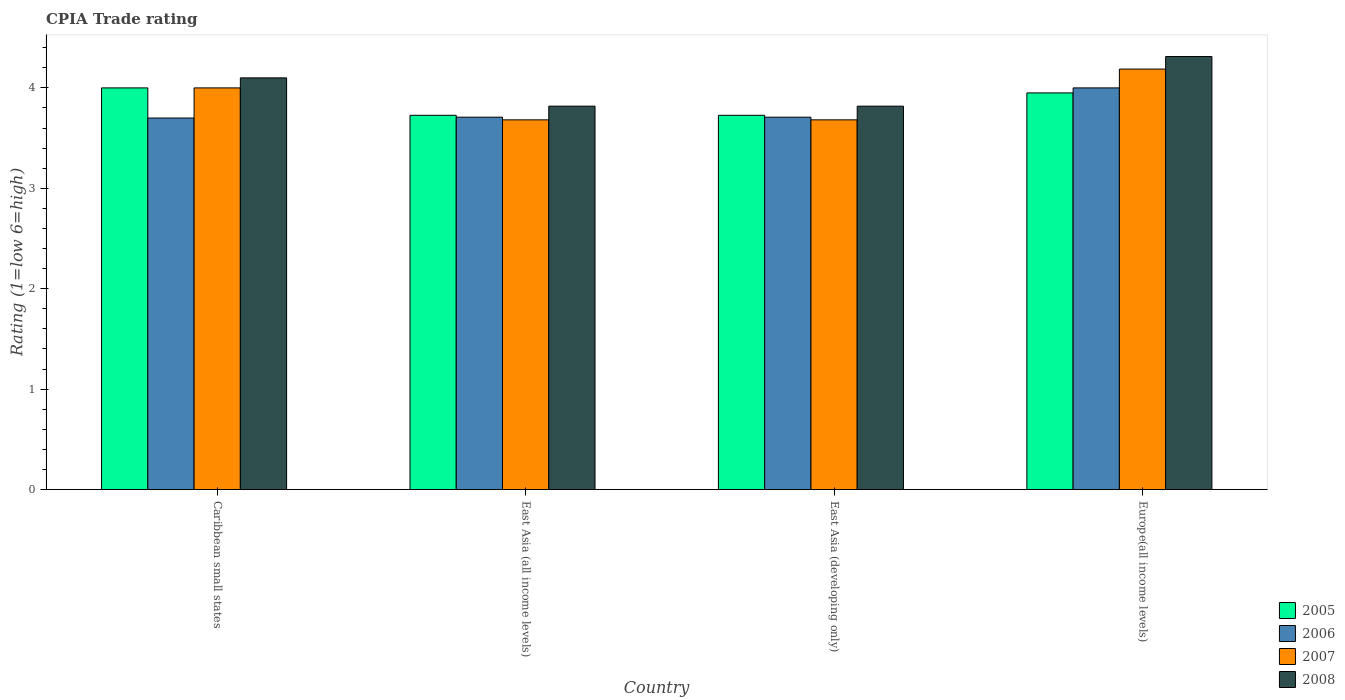Are the number of bars per tick equal to the number of legend labels?
Ensure brevity in your answer.  Yes. Are the number of bars on each tick of the X-axis equal?
Ensure brevity in your answer.  Yes. How many bars are there on the 3rd tick from the right?
Keep it short and to the point. 4. What is the label of the 3rd group of bars from the left?
Keep it short and to the point. East Asia (developing only). What is the CPIA rating in 2007 in East Asia (developing only)?
Offer a very short reply. 3.68. Across all countries, what is the minimum CPIA rating in 2008?
Make the answer very short. 3.82. In which country was the CPIA rating in 2005 maximum?
Your answer should be compact. Caribbean small states. In which country was the CPIA rating in 2008 minimum?
Offer a very short reply. East Asia (all income levels). What is the total CPIA rating in 2006 in the graph?
Offer a very short reply. 15.12. What is the difference between the CPIA rating in 2008 in East Asia (all income levels) and that in Europe(all income levels)?
Provide a succinct answer. -0.49. What is the average CPIA rating in 2005 per country?
Offer a very short reply. 3.85. What is the difference between the CPIA rating of/in 2006 and CPIA rating of/in 2005 in Caribbean small states?
Give a very brief answer. -0.3. What is the ratio of the CPIA rating in 2007 in Caribbean small states to that in East Asia (developing only)?
Keep it short and to the point. 1.09. Is the CPIA rating in 2005 in Caribbean small states less than that in East Asia (all income levels)?
Provide a short and direct response. No. What is the difference between the highest and the second highest CPIA rating in 2006?
Make the answer very short. -0.29. What is the difference between the highest and the lowest CPIA rating in 2007?
Provide a succinct answer. 0.51. Is the sum of the CPIA rating in 2007 in Caribbean small states and East Asia (all income levels) greater than the maximum CPIA rating in 2008 across all countries?
Your answer should be very brief. Yes. Is it the case that in every country, the sum of the CPIA rating in 2007 and CPIA rating in 2008 is greater than the sum of CPIA rating in 2005 and CPIA rating in 2006?
Your response must be concise. Yes. What does the 1st bar from the right in East Asia (developing only) represents?
Ensure brevity in your answer.  2008. Is it the case that in every country, the sum of the CPIA rating in 2006 and CPIA rating in 2007 is greater than the CPIA rating in 2008?
Provide a short and direct response. Yes. How many bars are there?
Make the answer very short. 16. How many countries are there in the graph?
Provide a succinct answer. 4. Are the values on the major ticks of Y-axis written in scientific E-notation?
Keep it short and to the point. No. Does the graph contain any zero values?
Your answer should be very brief. No. Does the graph contain grids?
Keep it short and to the point. No. How many legend labels are there?
Make the answer very short. 4. How are the legend labels stacked?
Ensure brevity in your answer.  Vertical. What is the title of the graph?
Your answer should be compact. CPIA Trade rating. Does "1965" appear as one of the legend labels in the graph?
Keep it short and to the point. No. What is the Rating (1=low 6=high) in 2005 in Caribbean small states?
Your answer should be compact. 4. What is the Rating (1=low 6=high) of 2006 in Caribbean small states?
Provide a short and direct response. 3.7. What is the Rating (1=low 6=high) of 2005 in East Asia (all income levels)?
Your response must be concise. 3.73. What is the Rating (1=low 6=high) of 2006 in East Asia (all income levels)?
Make the answer very short. 3.71. What is the Rating (1=low 6=high) of 2007 in East Asia (all income levels)?
Your response must be concise. 3.68. What is the Rating (1=low 6=high) in 2008 in East Asia (all income levels)?
Give a very brief answer. 3.82. What is the Rating (1=low 6=high) in 2005 in East Asia (developing only)?
Ensure brevity in your answer.  3.73. What is the Rating (1=low 6=high) in 2006 in East Asia (developing only)?
Your response must be concise. 3.71. What is the Rating (1=low 6=high) of 2007 in East Asia (developing only)?
Your response must be concise. 3.68. What is the Rating (1=low 6=high) in 2008 in East Asia (developing only)?
Keep it short and to the point. 3.82. What is the Rating (1=low 6=high) in 2005 in Europe(all income levels)?
Offer a terse response. 3.95. What is the Rating (1=low 6=high) in 2007 in Europe(all income levels)?
Your response must be concise. 4.19. What is the Rating (1=low 6=high) in 2008 in Europe(all income levels)?
Give a very brief answer. 4.31. Across all countries, what is the maximum Rating (1=low 6=high) in 2006?
Give a very brief answer. 4. Across all countries, what is the maximum Rating (1=low 6=high) of 2007?
Keep it short and to the point. 4.19. Across all countries, what is the maximum Rating (1=low 6=high) of 2008?
Offer a very short reply. 4.31. Across all countries, what is the minimum Rating (1=low 6=high) of 2005?
Your answer should be compact. 3.73. Across all countries, what is the minimum Rating (1=low 6=high) of 2006?
Offer a very short reply. 3.7. Across all countries, what is the minimum Rating (1=low 6=high) of 2007?
Keep it short and to the point. 3.68. Across all countries, what is the minimum Rating (1=low 6=high) in 2008?
Your answer should be very brief. 3.82. What is the total Rating (1=low 6=high) of 2005 in the graph?
Ensure brevity in your answer.  15.4. What is the total Rating (1=low 6=high) in 2006 in the graph?
Keep it short and to the point. 15.12. What is the total Rating (1=low 6=high) in 2007 in the graph?
Provide a short and direct response. 15.55. What is the total Rating (1=low 6=high) in 2008 in the graph?
Your answer should be very brief. 16.05. What is the difference between the Rating (1=low 6=high) of 2005 in Caribbean small states and that in East Asia (all income levels)?
Your answer should be compact. 0.27. What is the difference between the Rating (1=low 6=high) of 2006 in Caribbean small states and that in East Asia (all income levels)?
Your response must be concise. -0.01. What is the difference between the Rating (1=low 6=high) in 2007 in Caribbean small states and that in East Asia (all income levels)?
Your answer should be compact. 0.32. What is the difference between the Rating (1=low 6=high) of 2008 in Caribbean small states and that in East Asia (all income levels)?
Provide a short and direct response. 0.28. What is the difference between the Rating (1=low 6=high) of 2005 in Caribbean small states and that in East Asia (developing only)?
Keep it short and to the point. 0.27. What is the difference between the Rating (1=low 6=high) in 2006 in Caribbean small states and that in East Asia (developing only)?
Your answer should be compact. -0.01. What is the difference between the Rating (1=low 6=high) of 2007 in Caribbean small states and that in East Asia (developing only)?
Offer a terse response. 0.32. What is the difference between the Rating (1=low 6=high) in 2008 in Caribbean small states and that in East Asia (developing only)?
Your answer should be compact. 0.28. What is the difference between the Rating (1=low 6=high) in 2005 in Caribbean small states and that in Europe(all income levels)?
Your response must be concise. 0.05. What is the difference between the Rating (1=low 6=high) in 2006 in Caribbean small states and that in Europe(all income levels)?
Provide a succinct answer. -0.3. What is the difference between the Rating (1=low 6=high) of 2007 in Caribbean small states and that in Europe(all income levels)?
Keep it short and to the point. -0.19. What is the difference between the Rating (1=low 6=high) of 2008 in Caribbean small states and that in Europe(all income levels)?
Make the answer very short. -0.21. What is the difference between the Rating (1=low 6=high) in 2005 in East Asia (all income levels) and that in East Asia (developing only)?
Keep it short and to the point. 0. What is the difference between the Rating (1=low 6=high) in 2008 in East Asia (all income levels) and that in East Asia (developing only)?
Provide a succinct answer. 0. What is the difference between the Rating (1=low 6=high) of 2005 in East Asia (all income levels) and that in Europe(all income levels)?
Make the answer very short. -0.22. What is the difference between the Rating (1=low 6=high) in 2006 in East Asia (all income levels) and that in Europe(all income levels)?
Make the answer very short. -0.29. What is the difference between the Rating (1=low 6=high) of 2007 in East Asia (all income levels) and that in Europe(all income levels)?
Keep it short and to the point. -0.51. What is the difference between the Rating (1=low 6=high) of 2008 in East Asia (all income levels) and that in Europe(all income levels)?
Your response must be concise. -0.49. What is the difference between the Rating (1=low 6=high) of 2005 in East Asia (developing only) and that in Europe(all income levels)?
Make the answer very short. -0.22. What is the difference between the Rating (1=low 6=high) in 2006 in East Asia (developing only) and that in Europe(all income levels)?
Your answer should be compact. -0.29. What is the difference between the Rating (1=low 6=high) of 2007 in East Asia (developing only) and that in Europe(all income levels)?
Your response must be concise. -0.51. What is the difference between the Rating (1=low 6=high) in 2008 in East Asia (developing only) and that in Europe(all income levels)?
Your answer should be very brief. -0.49. What is the difference between the Rating (1=low 6=high) in 2005 in Caribbean small states and the Rating (1=low 6=high) in 2006 in East Asia (all income levels)?
Offer a very short reply. 0.29. What is the difference between the Rating (1=low 6=high) of 2005 in Caribbean small states and the Rating (1=low 6=high) of 2007 in East Asia (all income levels)?
Provide a short and direct response. 0.32. What is the difference between the Rating (1=low 6=high) in 2005 in Caribbean small states and the Rating (1=low 6=high) in 2008 in East Asia (all income levels)?
Offer a very short reply. 0.18. What is the difference between the Rating (1=low 6=high) in 2006 in Caribbean small states and the Rating (1=low 6=high) in 2007 in East Asia (all income levels)?
Make the answer very short. 0.02. What is the difference between the Rating (1=low 6=high) of 2006 in Caribbean small states and the Rating (1=low 6=high) of 2008 in East Asia (all income levels)?
Offer a terse response. -0.12. What is the difference between the Rating (1=low 6=high) of 2007 in Caribbean small states and the Rating (1=low 6=high) of 2008 in East Asia (all income levels)?
Your answer should be compact. 0.18. What is the difference between the Rating (1=low 6=high) in 2005 in Caribbean small states and the Rating (1=low 6=high) in 2006 in East Asia (developing only)?
Provide a short and direct response. 0.29. What is the difference between the Rating (1=low 6=high) of 2005 in Caribbean small states and the Rating (1=low 6=high) of 2007 in East Asia (developing only)?
Provide a succinct answer. 0.32. What is the difference between the Rating (1=low 6=high) of 2005 in Caribbean small states and the Rating (1=low 6=high) of 2008 in East Asia (developing only)?
Make the answer very short. 0.18. What is the difference between the Rating (1=low 6=high) of 2006 in Caribbean small states and the Rating (1=low 6=high) of 2007 in East Asia (developing only)?
Offer a very short reply. 0.02. What is the difference between the Rating (1=low 6=high) in 2006 in Caribbean small states and the Rating (1=low 6=high) in 2008 in East Asia (developing only)?
Keep it short and to the point. -0.12. What is the difference between the Rating (1=low 6=high) in 2007 in Caribbean small states and the Rating (1=low 6=high) in 2008 in East Asia (developing only)?
Your answer should be very brief. 0.18. What is the difference between the Rating (1=low 6=high) of 2005 in Caribbean small states and the Rating (1=low 6=high) of 2007 in Europe(all income levels)?
Your answer should be very brief. -0.19. What is the difference between the Rating (1=low 6=high) in 2005 in Caribbean small states and the Rating (1=low 6=high) in 2008 in Europe(all income levels)?
Your answer should be compact. -0.31. What is the difference between the Rating (1=low 6=high) of 2006 in Caribbean small states and the Rating (1=low 6=high) of 2007 in Europe(all income levels)?
Give a very brief answer. -0.49. What is the difference between the Rating (1=low 6=high) in 2006 in Caribbean small states and the Rating (1=low 6=high) in 2008 in Europe(all income levels)?
Offer a very short reply. -0.61. What is the difference between the Rating (1=low 6=high) of 2007 in Caribbean small states and the Rating (1=low 6=high) of 2008 in Europe(all income levels)?
Keep it short and to the point. -0.31. What is the difference between the Rating (1=low 6=high) of 2005 in East Asia (all income levels) and the Rating (1=low 6=high) of 2006 in East Asia (developing only)?
Provide a short and direct response. 0.02. What is the difference between the Rating (1=low 6=high) of 2005 in East Asia (all income levels) and the Rating (1=low 6=high) of 2007 in East Asia (developing only)?
Offer a terse response. 0.05. What is the difference between the Rating (1=low 6=high) of 2005 in East Asia (all income levels) and the Rating (1=low 6=high) of 2008 in East Asia (developing only)?
Provide a short and direct response. -0.09. What is the difference between the Rating (1=low 6=high) of 2006 in East Asia (all income levels) and the Rating (1=low 6=high) of 2007 in East Asia (developing only)?
Your answer should be compact. 0.03. What is the difference between the Rating (1=low 6=high) of 2006 in East Asia (all income levels) and the Rating (1=low 6=high) of 2008 in East Asia (developing only)?
Offer a terse response. -0.11. What is the difference between the Rating (1=low 6=high) of 2007 in East Asia (all income levels) and the Rating (1=low 6=high) of 2008 in East Asia (developing only)?
Ensure brevity in your answer.  -0.14. What is the difference between the Rating (1=low 6=high) in 2005 in East Asia (all income levels) and the Rating (1=low 6=high) in 2006 in Europe(all income levels)?
Keep it short and to the point. -0.27. What is the difference between the Rating (1=low 6=high) of 2005 in East Asia (all income levels) and the Rating (1=low 6=high) of 2007 in Europe(all income levels)?
Ensure brevity in your answer.  -0.46. What is the difference between the Rating (1=low 6=high) in 2005 in East Asia (all income levels) and the Rating (1=low 6=high) in 2008 in Europe(all income levels)?
Provide a short and direct response. -0.59. What is the difference between the Rating (1=low 6=high) of 2006 in East Asia (all income levels) and the Rating (1=low 6=high) of 2007 in Europe(all income levels)?
Your response must be concise. -0.48. What is the difference between the Rating (1=low 6=high) in 2006 in East Asia (all income levels) and the Rating (1=low 6=high) in 2008 in Europe(all income levels)?
Your answer should be compact. -0.6. What is the difference between the Rating (1=low 6=high) in 2007 in East Asia (all income levels) and the Rating (1=low 6=high) in 2008 in Europe(all income levels)?
Offer a terse response. -0.63. What is the difference between the Rating (1=low 6=high) of 2005 in East Asia (developing only) and the Rating (1=low 6=high) of 2006 in Europe(all income levels)?
Ensure brevity in your answer.  -0.27. What is the difference between the Rating (1=low 6=high) of 2005 in East Asia (developing only) and the Rating (1=low 6=high) of 2007 in Europe(all income levels)?
Your response must be concise. -0.46. What is the difference between the Rating (1=low 6=high) of 2005 in East Asia (developing only) and the Rating (1=low 6=high) of 2008 in Europe(all income levels)?
Your answer should be very brief. -0.59. What is the difference between the Rating (1=low 6=high) in 2006 in East Asia (developing only) and the Rating (1=low 6=high) in 2007 in Europe(all income levels)?
Your answer should be very brief. -0.48. What is the difference between the Rating (1=low 6=high) of 2006 in East Asia (developing only) and the Rating (1=low 6=high) of 2008 in Europe(all income levels)?
Your answer should be very brief. -0.6. What is the difference between the Rating (1=low 6=high) in 2007 in East Asia (developing only) and the Rating (1=low 6=high) in 2008 in Europe(all income levels)?
Make the answer very short. -0.63. What is the average Rating (1=low 6=high) in 2005 per country?
Keep it short and to the point. 3.85. What is the average Rating (1=low 6=high) in 2006 per country?
Keep it short and to the point. 3.78. What is the average Rating (1=low 6=high) in 2007 per country?
Offer a very short reply. 3.89. What is the average Rating (1=low 6=high) of 2008 per country?
Provide a short and direct response. 4.01. What is the difference between the Rating (1=low 6=high) in 2006 and Rating (1=low 6=high) in 2008 in Caribbean small states?
Keep it short and to the point. -0.4. What is the difference between the Rating (1=low 6=high) of 2005 and Rating (1=low 6=high) of 2006 in East Asia (all income levels)?
Offer a terse response. 0.02. What is the difference between the Rating (1=low 6=high) in 2005 and Rating (1=low 6=high) in 2007 in East Asia (all income levels)?
Your response must be concise. 0.05. What is the difference between the Rating (1=low 6=high) of 2005 and Rating (1=low 6=high) of 2008 in East Asia (all income levels)?
Keep it short and to the point. -0.09. What is the difference between the Rating (1=low 6=high) in 2006 and Rating (1=low 6=high) in 2007 in East Asia (all income levels)?
Offer a very short reply. 0.03. What is the difference between the Rating (1=low 6=high) in 2006 and Rating (1=low 6=high) in 2008 in East Asia (all income levels)?
Keep it short and to the point. -0.11. What is the difference between the Rating (1=low 6=high) in 2007 and Rating (1=low 6=high) in 2008 in East Asia (all income levels)?
Provide a short and direct response. -0.14. What is the difference between the Rating (1=low 6=high) of 2005 and Rating (1=low 6=high) of 2006 in East Asia (developing only)?
Give a very brief answer. 0.02. What is the difference between the Rating (1=low 6=high) of 2005 and Rating (1=low 6=high) of 2007 in East Asia (developing only)?
Your response must be concise. 0.05. What is the difference between the Rating (1=low 6=high) in 2005 and Rating (1=low 6=high) in 2008 in East Asia (developing only)?
Provide a short and direct response. -0.09. What is the difference between the Rating (1=low 6=high) in 2006 and Rating (1=low 6=high) in 2007 in East Asia (developing only)?
Keep it short and to the point. 0.03. What is the difference between the Rating (1=low 6=high) in 2006 and Rating (1=low 6=high) in 2008 in East Asia (developing only)?
Your answer should be very brief. -0.11. What is the difference between the Rating (1=low 6=high) of 2007 and Rating (1=low 6=high) of 2008 in East Asia (developing only)?
Your answer should be compact. -0.14. What is the difference between the Rating (1=low 6=high) of 2005 and Rating (1=low 6=high) of 2007 in Europe(all income levels)?
Your response must be concise. -0.24. What is the difference between the Rating (1=low 6=high) of 2005 and Rating (1=low 6=high) of 2008 in Europe(all income levels)?
Provide a short and direct response. -0.36. What is the difference between the Rating (1=low 6=high) of 2006 and Rating (1=low 6=high) of 2007 in Europe(all income levels)?
Make the answer very short. -0.19. What is the difference between the Rating (1=low 6=high) in 2006 and Rating (1=low 6=high) in 2008 in Europe(all income levels)?
Provide a succinct answer. -0.31. What is the difference between the Rating (1=low 6=high) in 2007 and Rating (1=low 6=high) in 2008 in Europe(all income levels)?
Give a very brief answer. -0.12. What is the ratio of the Rating (1=low 6=high) of 2005 in Caribbean small states to that in East Asia (all income levels)?
Keep it short and to the point. 1.07. What is the ratio of the Rating (1=low 6=high) in 2006 in Caribbean small states to that in East Asia (all income levels)?
Give a very brief answer. 1. What is the ratio of the Rating (1=low 6=high) in 2007 in Caribbean small states to that in East Asia (all income levels)?
Make the answer very short. 1.09. What is the ratio of the Rating (1=low 6=high) of 2008 in Caribbean small states to that in East Asia (all income levels)?
Provide a succinct answer. 1.07. What is the ratio of the Rating (1=low 6=high) of 2005 in Caribbean small states to that in East Asia (developing only)?
Provide a short and direct response. 1.07. What is the ratio of the Rating (1=low 6=high) of 2007 in Caribbean small states to that in East Asia (developing only)?
Ensure brevity in your answer.  1.09. What is the ratio of the Rating (1=low 6=high) in 2008 in Caribbean small states to that in East Asia (developing only)?
Make the answer very short. 1.07. What is the ratio of the Rating (1=low 6=high) of 2005 in Caribbean small states to that in Europe(all income levels)?
Your answer should be compact. 1.01. What is the ratio of the Rating (1=low 6=high) in 2006 in Caribbean small states to that in Europe(all income levels)?
Keep it short and to the point. 0.93. What is the ratio of the Rating (1=low 6=high) of 2007 in Caribbean small states to that in Europe(all income levels)?
Keep it short and to the point. 0.96. What is the ratio of the Rating (1=low 6=high) of 2008 in Caribbean small states to that in Europe(all income levels)?
Your response must be concise. 0.95. What is the ratio of the Rating (1=low 6=high) in 2005 in East Asia (all income levels) to that in Europe(all income levels)?
Make the answer very short. 0.94. What is the ratio of the Rating (1=low 6=high) in 2006 in East Asia (all income levels) to that in Europe(all income levels)?
Provide a succinct answer. 0.93. What is the ratio of the Rating (1=low 6=high) of 2007 in East Asia (all income levels) to that in Europe(all income levels)?
Provide a succinct answer. 0.88. What is the ratio of the Rating (1=low 6=high) of 2008 in East Asia (all income levels) to that in Europe(all income levels)?
Make the answer very short. 0.89. What is the ratio of the Rating (1=low 6=high) in 2005 in East Asia (developing only) to that in Europe(all income levels)?
Give a very brief answer. 0.94. What is the ratio of the Rating (1=low 6=high) of 2006 in East Asia (developing only) to that in Europe(all income levels)?
Keep it short and to the point. 0.93. What is the ratio of the Rating (1=low 6=high) in 2007 in East Asia (developing only) to that in Europe(all income levels)?
Provide a short and direct response. 0.88. What is the ratio of the Rating (1=low 6=high) in 2008 in East Asia (developing only) to that in Europe(all income levels)?
Provide a succinct answer. 0.89. What is the difference between the highest and the second highest Rating (1=low 6=high) of 2006?
Keep it short and to the point. 0.29. What is the difference between the highest and the second highest Rating (1=low 6=high) of 2007?
Keep it short and to the point. 0.19. What is the difference between the highest and the second highest Rating (1=low 6=high) of 2008?
Provide a succinct answer. 0.21. What is the difference between the highest and the lowest Rating (1=low 6=high) of 2005?
Provide a succinct answer. 0.27. What is the difference between the highest and the lowest Rating (1=low 6=high) in 2007?
Your answer should be compact. 0.51. What is the difference between the highest and the lowest Rating (1=low 6=high) of 2008?
Your response must be concise. 0.49. 